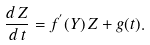<formula> <loc_0><loc_0><loc_500><loc_500>\frac { d \, Z } { d \, t } = f ^ { ^ { \prime } } ( Y ) \, Z + g ( t ) .</formula> 